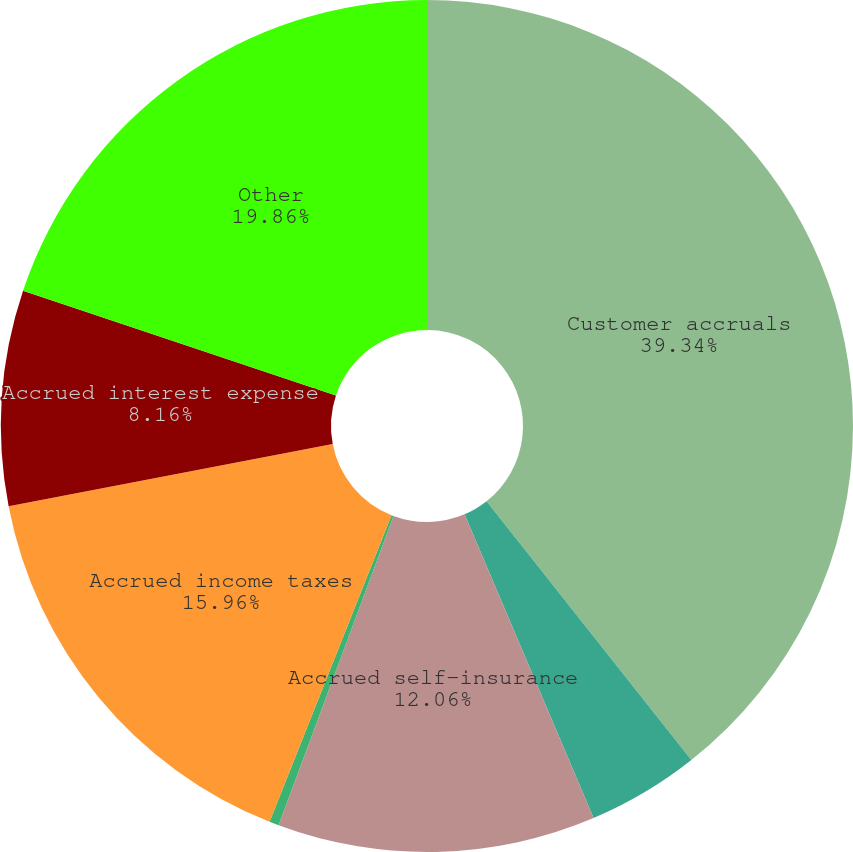Convert chart to OTSL. <chart><loc_0><loc_0><loc_500><loc_500><pie_chart><fcel>Customer accruals<fcel>Accruals for manufacturing<fcel>Accrued self-insurance<fcel>Derivative liabilities<fcel>Accrued income taxes<fcel>Accrued interest expense<fcel>Other<nl><fcel>39.35%<fcel>4.26%<fcel>12.06%<fcel>0.36%<fcel>15.96%<fcel>8.16%<fcel>19.86%<nl></chart> 